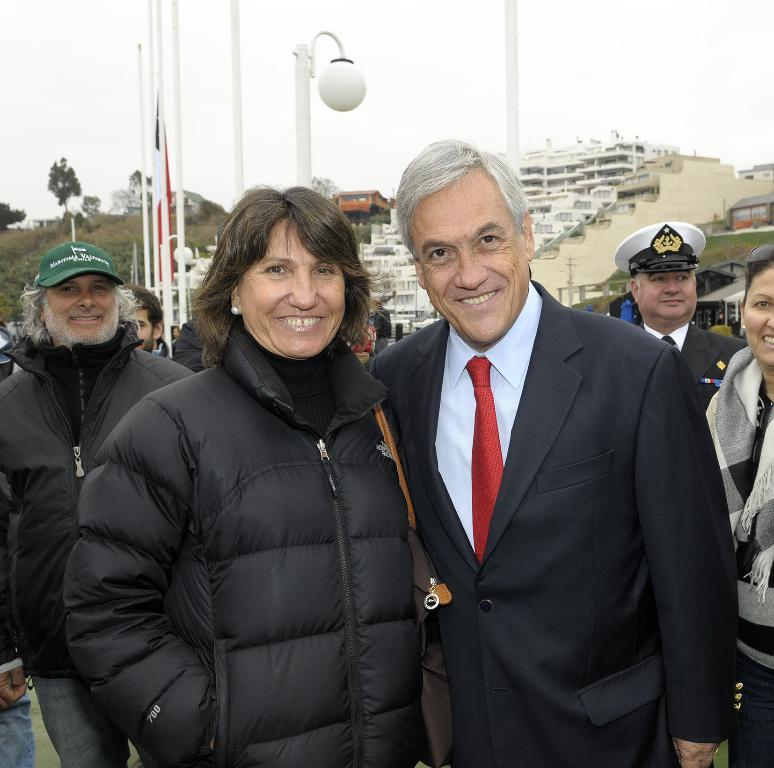What can be seen at the front of the image? There are persons standing at the front of the image. What is visible in the background of the image? Buildings, poles, light, grass, trees, and the sky are visible in the background of the image. What type of shirt is the spark wearing in the image? There is no spark or shirt present in the image. What is the condition of the spark in the image? There is no spark present in the image, so its condition cannot be determined. 